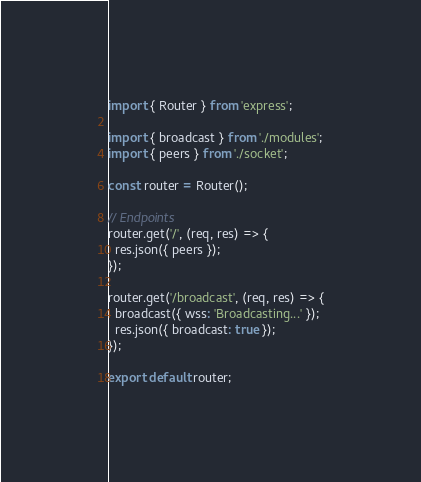<code> <loc_0><loc_0><loc_500><loc_500><_JavaScript_>import { Router } from 'express';

import { broadcast } from './modules';
import { peers } from './socket';

const router = Router();

// Endpoints
router.get('/', (req, res) => {
  res.json({ peers });
});

router.get('/broadcast', (req, res) => {
  broadcast({ wss: 'Broadcasting...' });
  res.json({ broadcast: true });
});

export default router;
</code> 